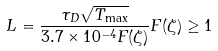Convert formula to latex. <formula><loc_0><loc_0><loc_500><loc_500>L = \frac { \tau _ { D } \sqrt { T _ { \max } } } { 3 . 7 \times 1 0 ^ { - 4 } F ( \zeta ) } F ( \zeta ) \geq 1</formula> 